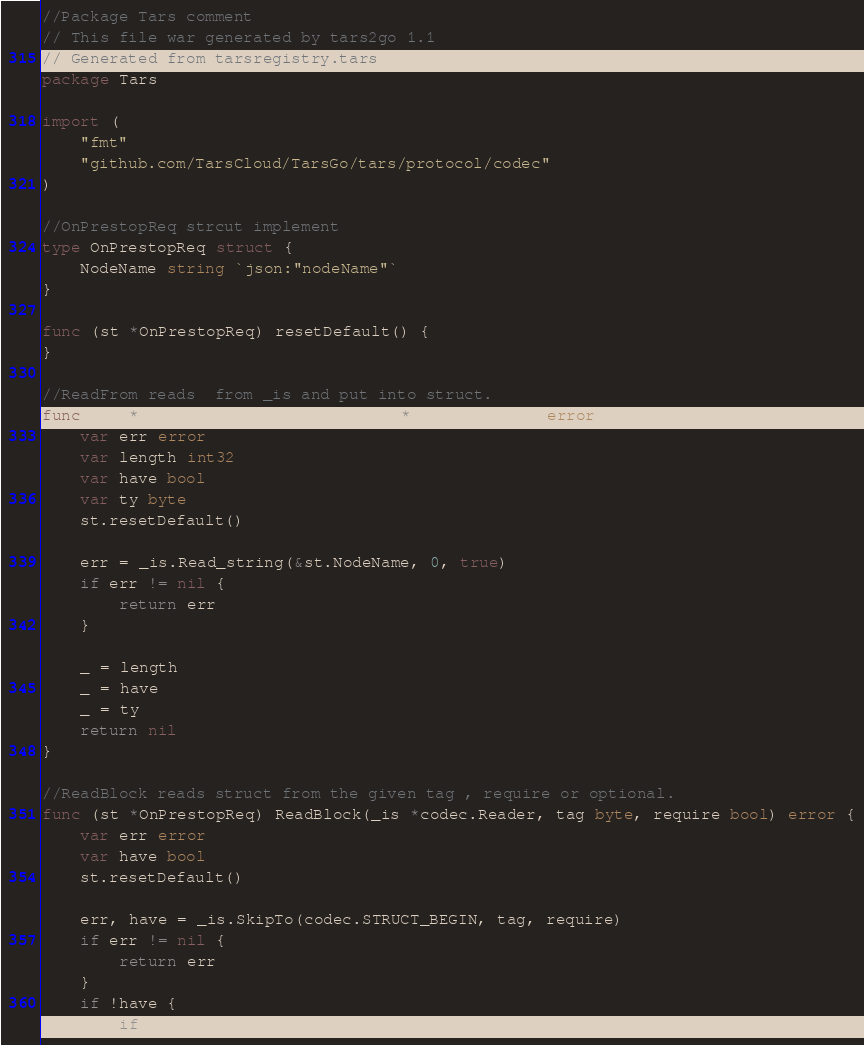<code> <loc_0><loc_0><loc_500><loc_500><_Go_>//Package Tars comment
// This file war generated by tars2go 1.1
// Generated from tarsregistry.tars
package Tars

import (
	"fmt"
	"github.com/TarsCloud/TarsGo/tars/protocol/codec"
)

//OnPrestopReq strcut implement
type OnPrestopReq struct {
	NodeName string `json:"nodeName"`
}

func (st *OnPrestopReq) resetDefault() {
}

//ReadFrom reads  from _is and put into struct.
func (st *OnPrestopReq) ReadFrom(_is *codec.Reader) error {
	var err error
	var length int32
	var have bool
	var ty byte
	st.resetDefault()

	err = _is.Read_string(&st.NodeName, 0, true)
	if err != nil {
		return err
	}

	_ = length
	_ = have
	_ = ty
	return nil
}

//ReadBlock reads struct from the given tag , require or optional.
func (st *OnPrestopReq) ReadBlock(_is *codec.Reader, tag byte, require bool) error {
	var err error
	var have bool
	st.resetDefault()

	err, have = _is.SkipTo(codec.STRUCT_BEGIN, tag, require)
	if err != nil {
		return err
	}
	if !have {
		if require {</code> 